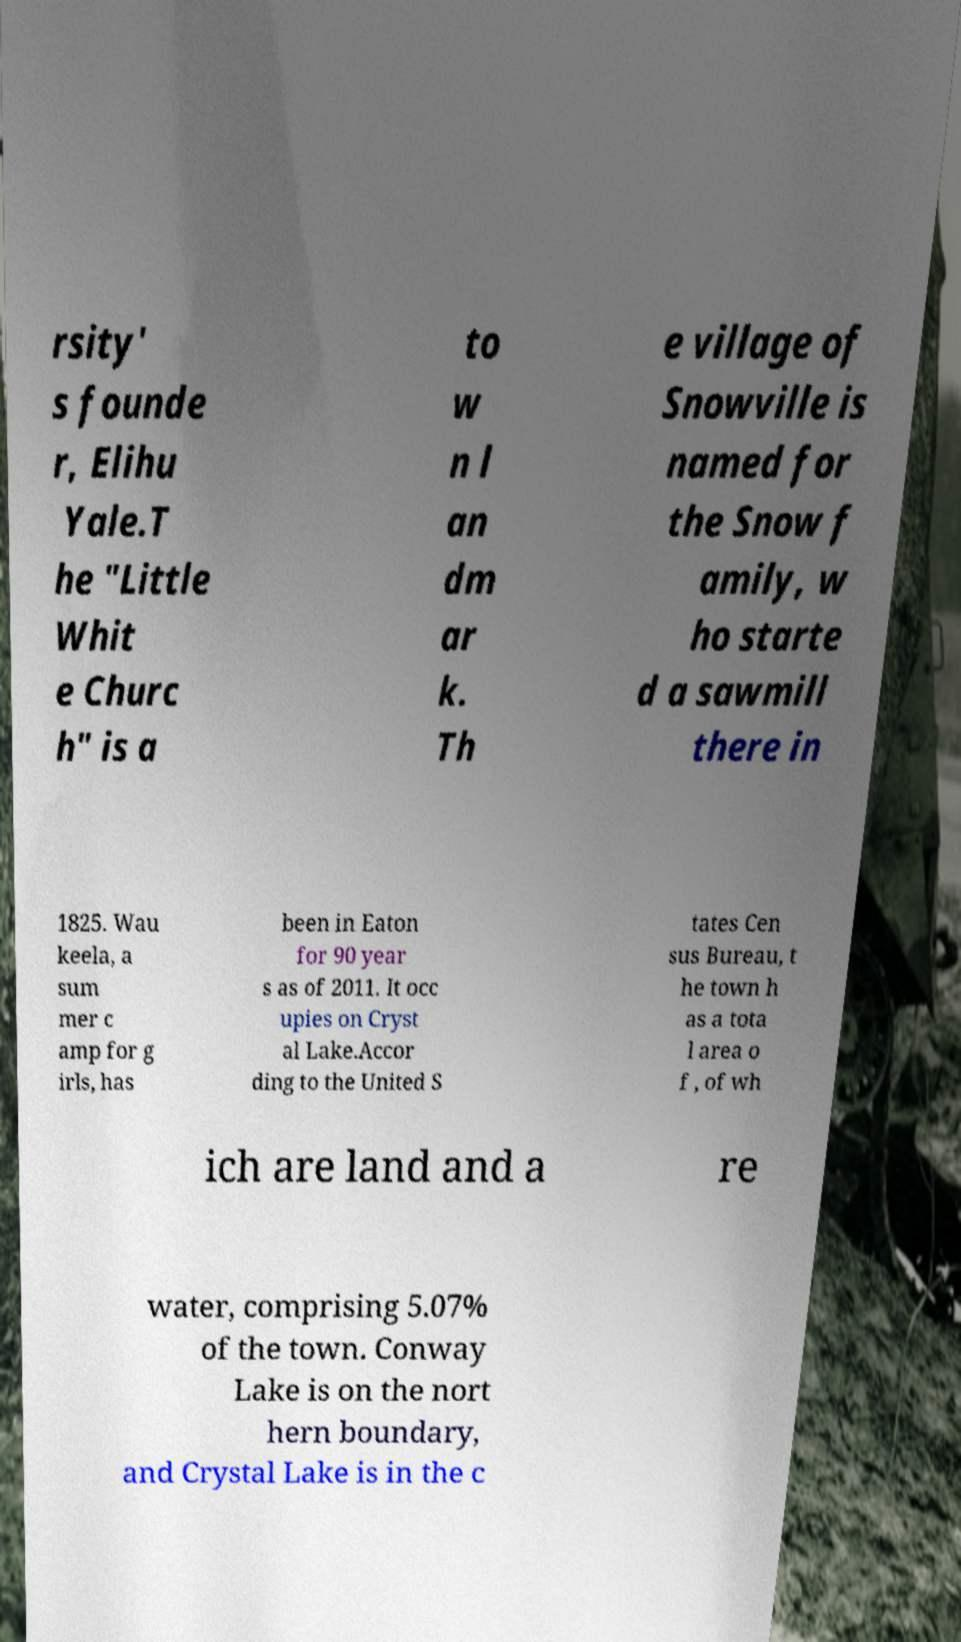Can you read and provide the text displayed in the image?This photo seems to have some interesting text. Can you extract and type it out for me? rsity' s founde r, Elihu Yale.T he "Little Whit e Churc h" is a to w n l an dm ar k. Th e village of Snowville is named for the Snow f amily, w ho starte d a sawmill there in 1825. Wau keela, a sum mer c amp for g irls, has been in Eaton for 90 year s as of 2011. It occ upies on Cryst al Lake.Accor ding to the United S tates Cen sus Bureau, t he town h as a tota l area o f , of wh ich are land and a re water, comprising 5.07% of the town. Conway Lake is on the nort hern boundary, and Crystal Lake is in the c 